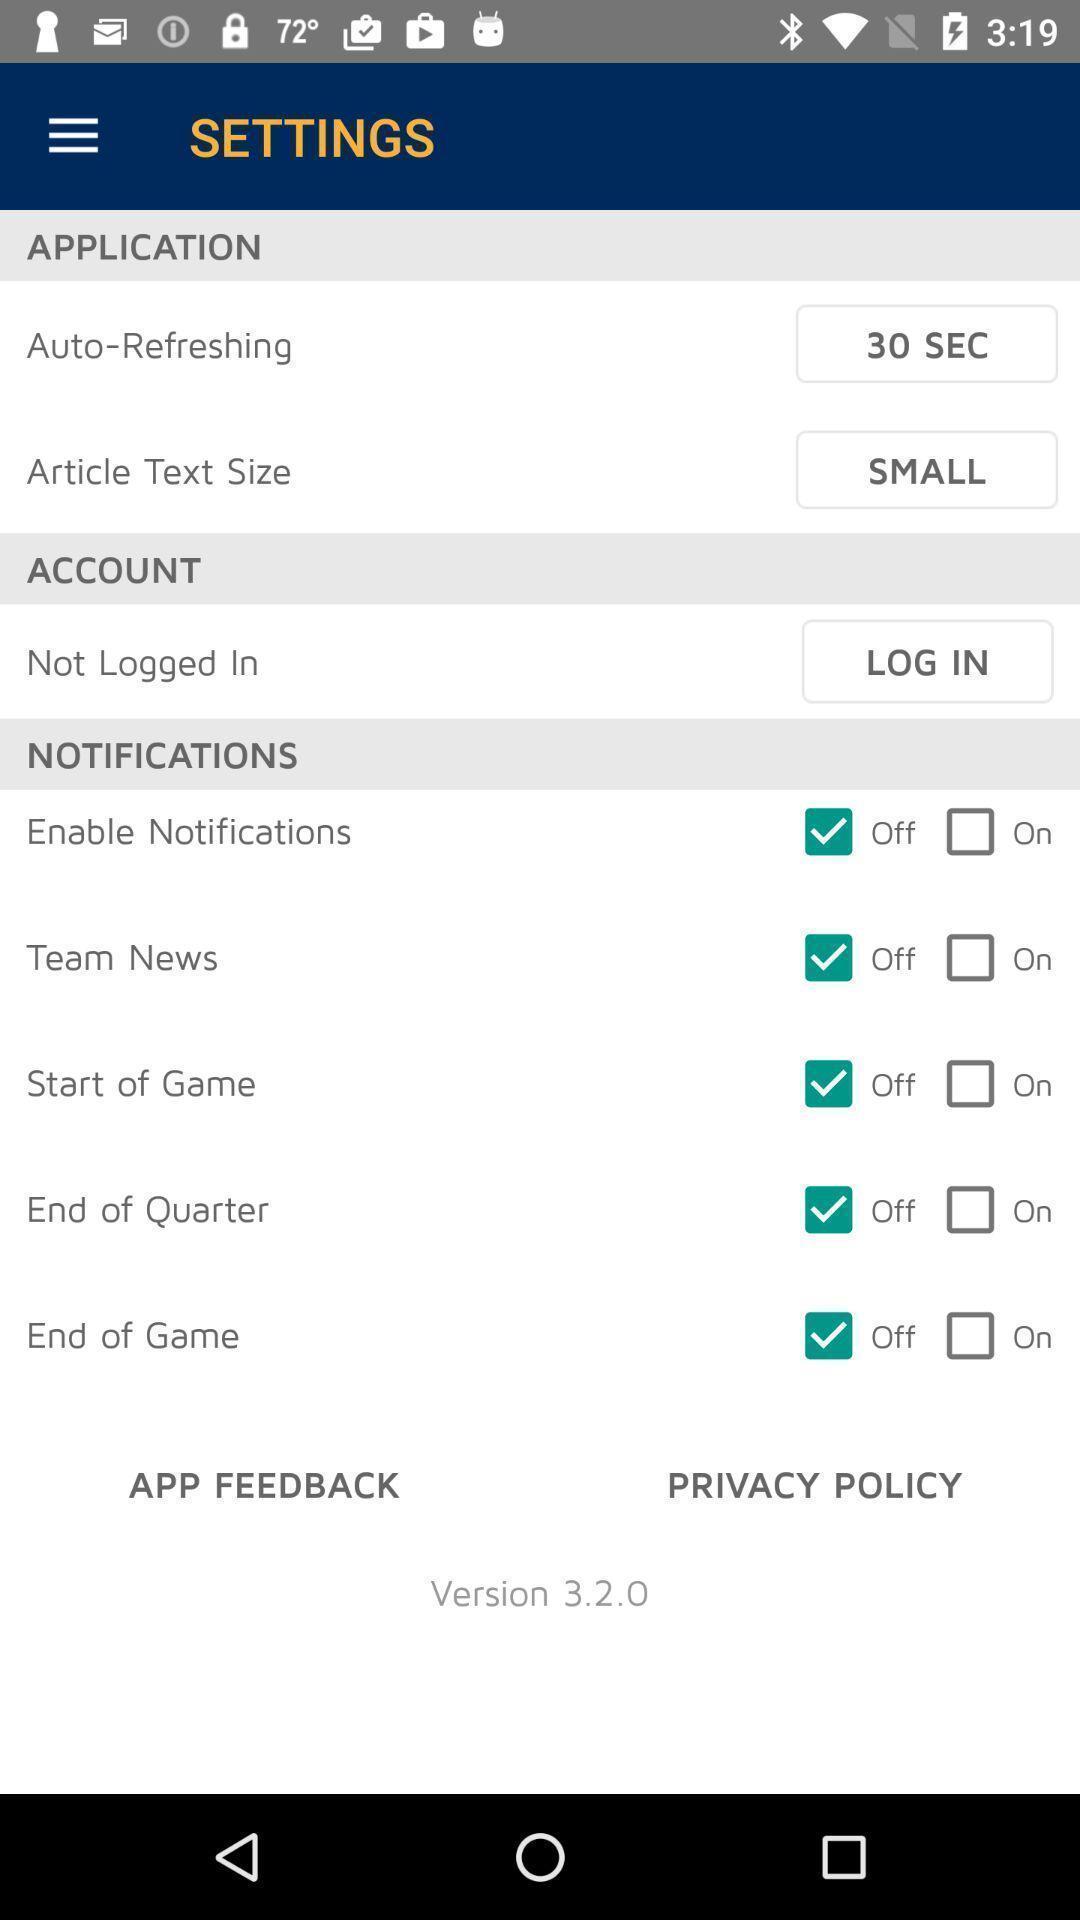Please provide a description for this image. Settings page. 